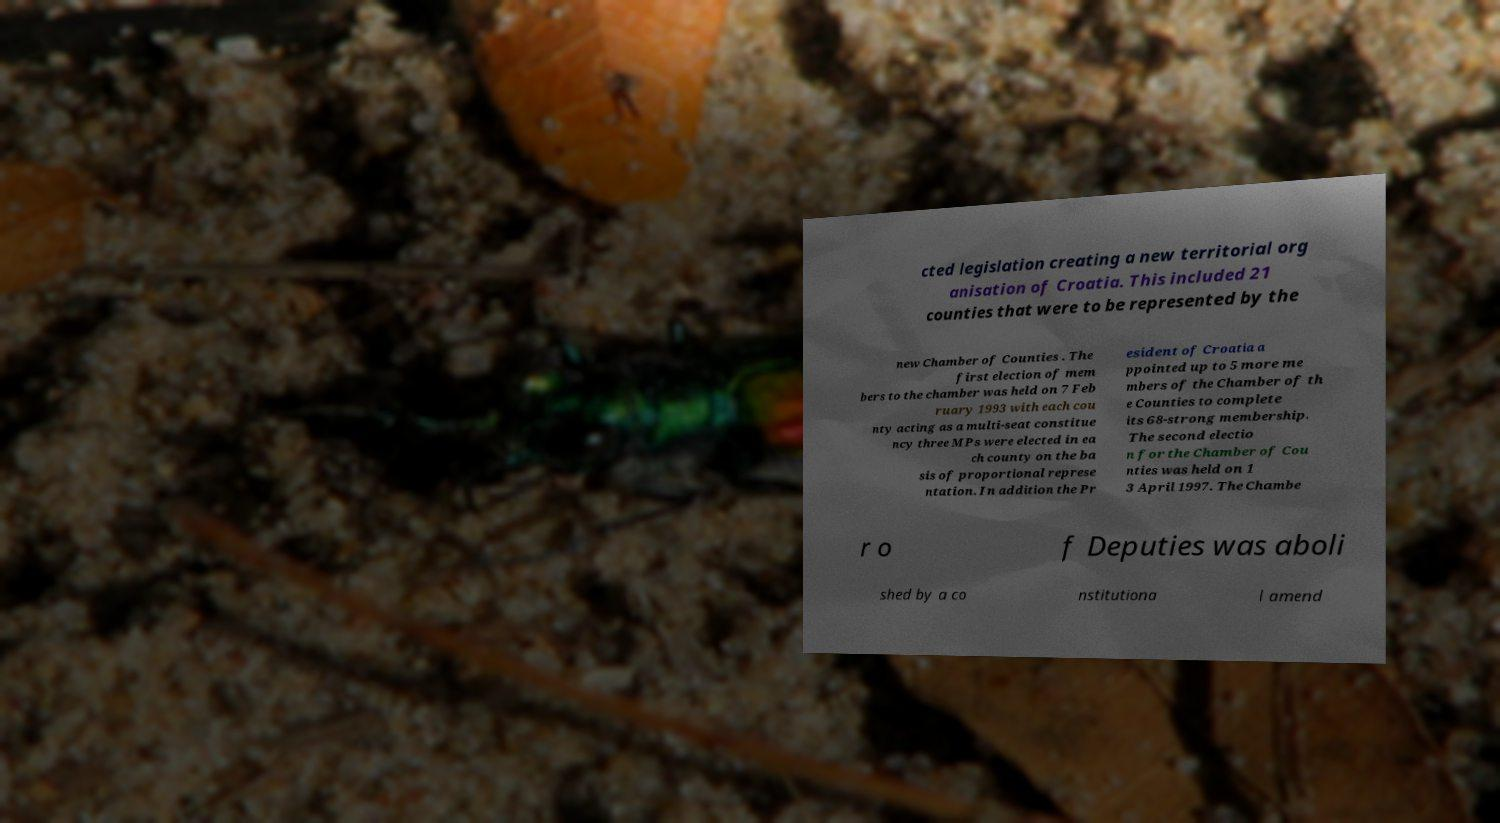What messages or text are displayed in this image? I need them in a readable, typed format. cted legislation creating a new territorial org anisation of Croatia. This included 21 counties that were to be represented by the new Chamber of Counties . The first election of mem bers to the chamber was held on 7 Feb ruary 1993 with each cou nty acting as a multi-seat constitue ncy three MPs were elected in ea ch county on the ba sis of proportional represe ntation. In addition the Pr esident of Croatia a ppointed up to 5 more me mbers of the Chamber of th e Counties to complete its 68-strong membership. The second electio n for the Chamber of Cou nties was held on 1 3 April 1997. The Chambe r o f Deputies was aboli shed by a co nstitutiona l amend 